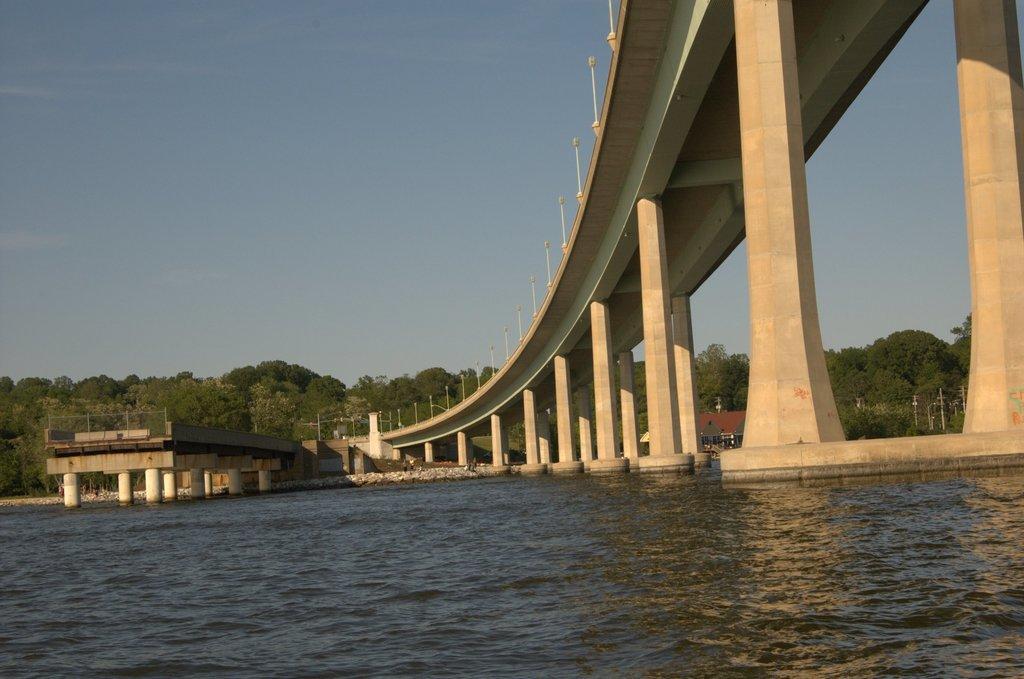Please provide a concise description of this image. In the foreground of the picture there is water. In the center of the picture towards right there is a bridge. In the middle of the picture there are trees, house, poles and a dock. Sky is clear and it is sunny. 